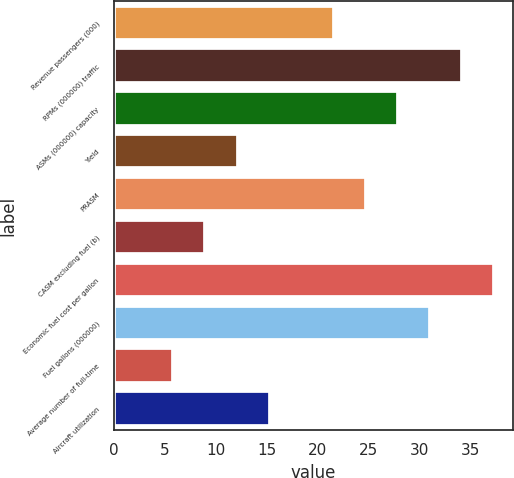Convert chart. <chart><loc_0><loc_0><loc_500><loc_500><bar_chart><fcel>Revenue passengers (000)<fcel>RPMs (000000) traffic<fcel>ASMs (000000) capacity<fcel>Yield<fcel>PRASM<fcel>CASM excluding fuel (b)<fcel>Economic fuel cost per gallon<fcel>Fuel gallons (000000)<fcel>Average number of full-time<fcel>Aircraft utilization<nl><fcel>21.6<fcel>34.2<fcel>27.9<fcel>12.15<fcel>24.75<fcel>9<fcel>37.35<fcel>31.05<fcel>5.85<fcel>15.3<nl></chart> 